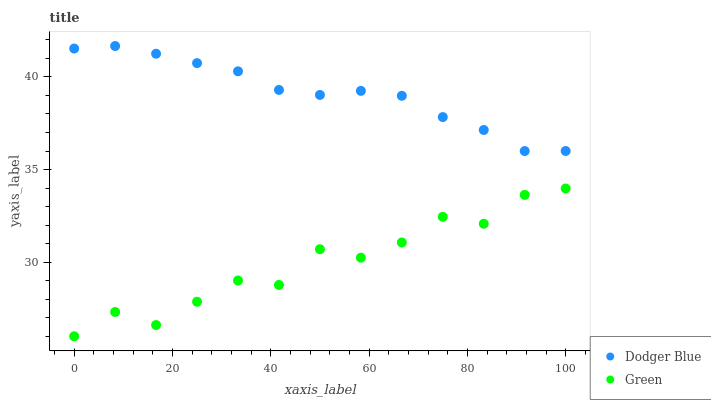Does Green have the minimum area under the curve?
Answer yes or no. Yes. Does Dodger Blue have the maximum area under the curve?
Answer yes or no. Yes. Does Dodger Blue have the minimum area under the curve?
Answer yes or no. No. Is Dodger Blue the smoothest?
Answer yes or no. Yes. Is Green the roughest?
Answer yes or no. Yes. Is Dodger Blue the roughest?
Answer yes or no. No. Does Green have the lowest value?
Answer yes or no. Yes. Does Dodger Blue have the lowest value?
Answer yes or no. No. Does Dodger Blue have the highest value?
Answer yes or no. Yes. Is Green less than Dodger Blue?
Answer yes or no. Yes. Is Dodger Blue greater than Green?
Answer yes or no. Yes. Does Green intersect Dodger Blue?
Answer yes or no. No. 